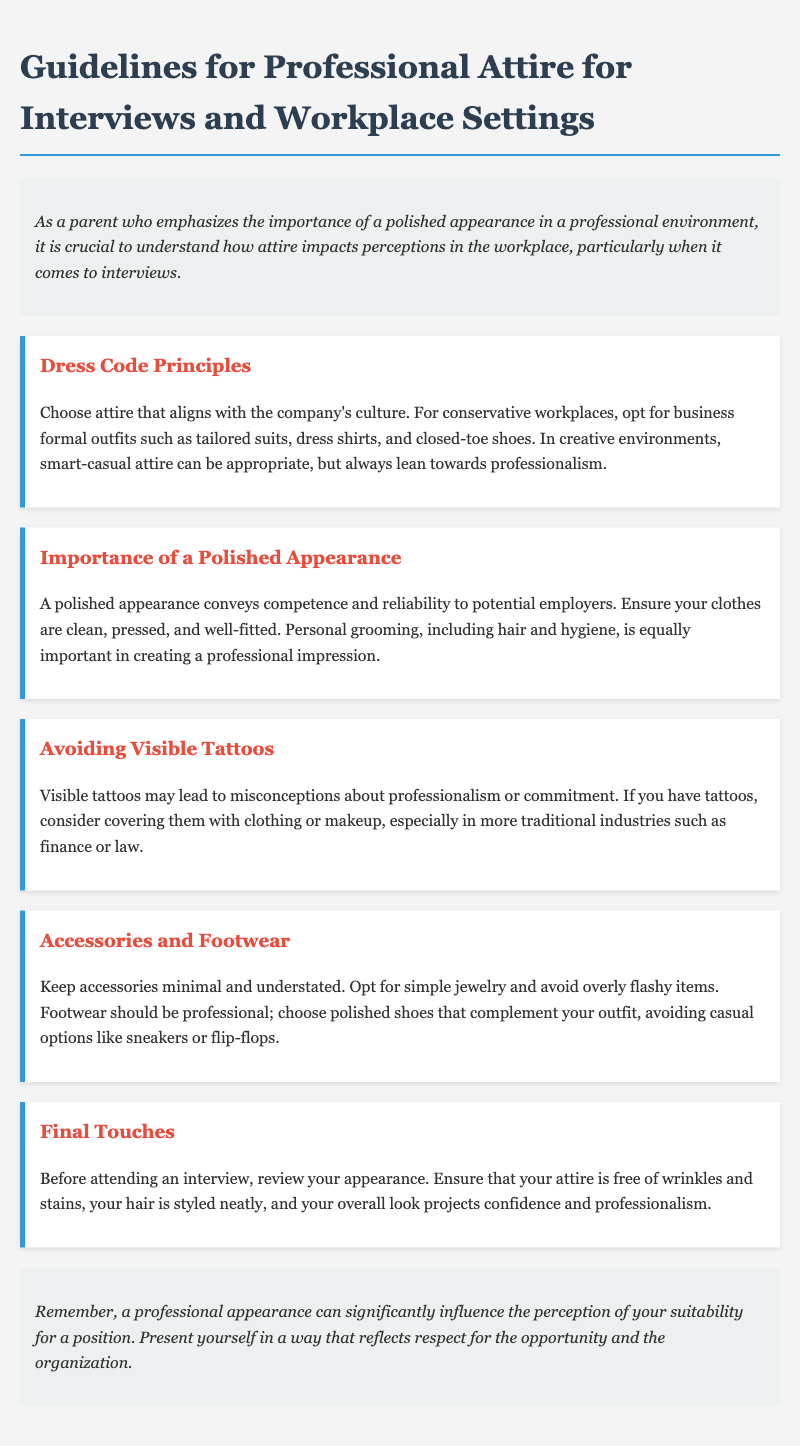What is the title of the document? The title is found in the heading section at the top of the document.
Answer: Guidelines for Professional Attire for Interviews and Workplace Settings What is emphasized to create a professional impression? The document describes aspects of personal appearance that are important for professional settings.
Answer: A polished appearance Which industry is mentioned regarding the avoidance of visible tattoos? The document lists industries that may not favor visible tattoos.
Answer: Finance or law What should footwear be described as? The specifics regarding footwear are found in the Accessories and Footwear section.
Answer: Professional What aspect of grooming is mentioned along with clothing? The document highlights an important personal care aspect related to appearance.
Answer: Personal grooming What should be minimal according to the accessories guideline? The guidelines specify what type of accessories should be limited.
Answer: Accessories How should attire be described for conservative workplaces? The document outlines specific types of clothing suitable for certain workplace environments.
Answer: Business formal outfits What is recommended to check before an interview? The last guideline emphasizes a final review of a specific aspect of readiness for an interview.
Answer: Your appearance 